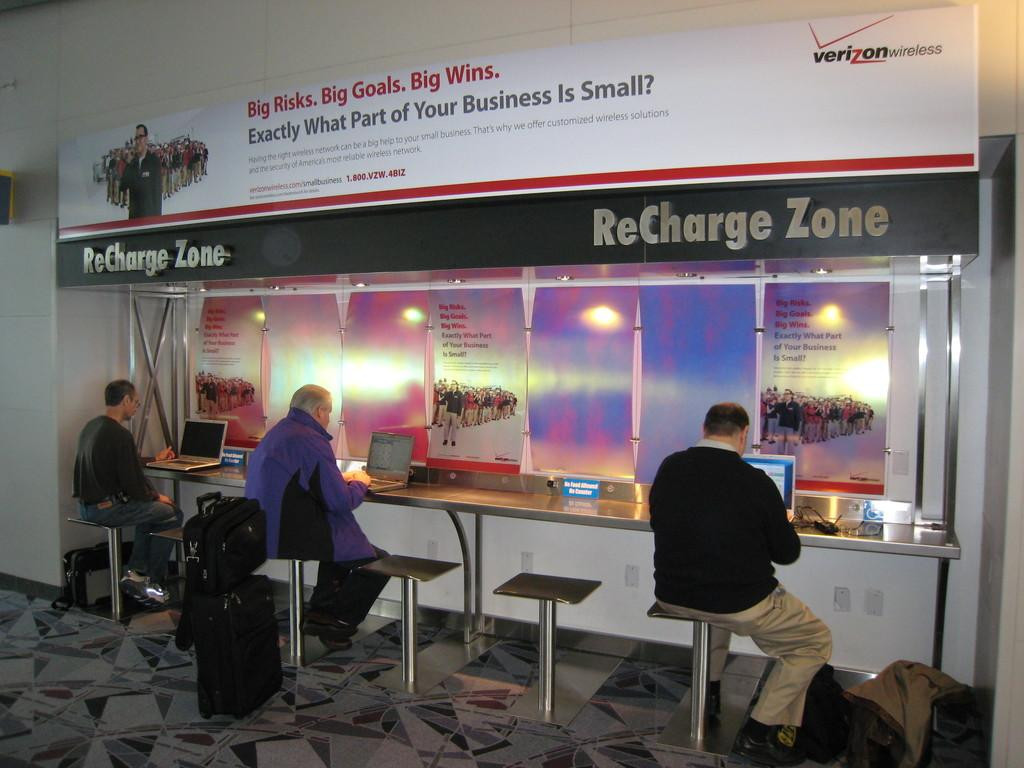<image>
Render a clear and concise summary of the photo. People sitting beneath a sign that reads ReCharge Zone. 